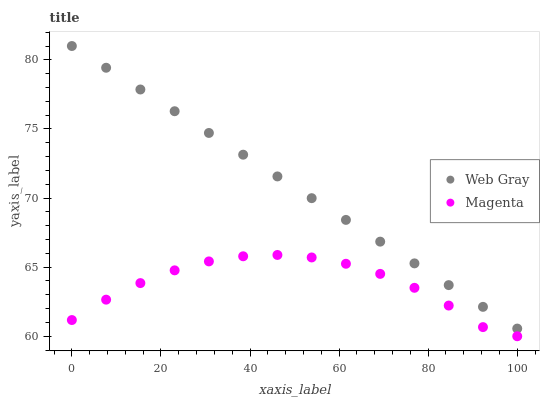Does Magenta have the minimum area under the curve?
Answer yes or no. Yes. Does Web Gray have the maximum area under the curve?
Answer yes or no. Yes. Does Web Gray have the minimum area under the curve?
Answer yes or no. No. Is Web Gray the smoothest?
Answer yes or no. Yes. Is Magenta the roughest?
Answer yes or no. Yes. Is Web Gray the roughest?
Answer yes or no. No. Does Magenta have the lowest value?
Answer yes or no. Yes. Does Web Gray have the lowest value?
Answer yes or no. No. Does Web Gray have the highest value?
Answer yes or no. Yes. Is Magenta less than Web Gray?
Answer yes or no. Yes. Is Web Gray greater than Magenta?
Answer yes or no. Yes. Does Magenta intersect Web Gray?
Answer yes or no. No. 